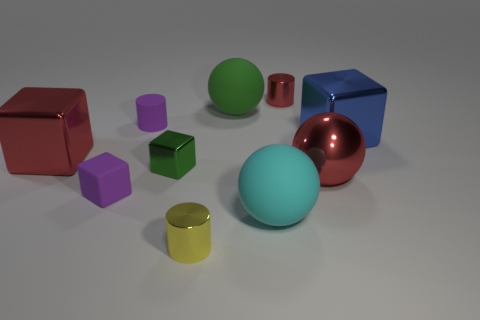What material is the purple cube that is the same size as the yellow cylinder? The purple cube, appearing equivalent in size to the yellow cylinder in the image, seems to have a matte surface similar to that of a plastic material, often used in objects designed for visual or educational purposes. 